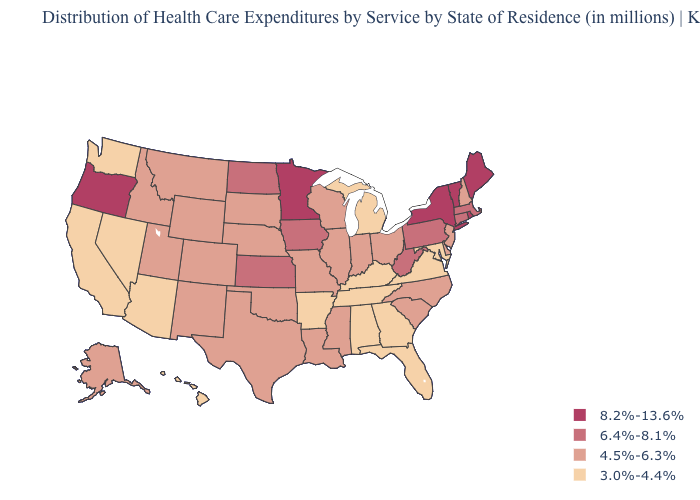Which states have the lowest value in the USA?
Concise answer only. Alabama, Arizona, Arkansas, California, Florida, Georgia, Hawaii, Kentucky, Maryland, Michigan, Nevada, Tennessee, Virginia, Washington. What is the lowest value in states that border Maine?
Short answer required. 4.5%-6.3%. What is the lowest value in the USA?
Keep it brief. 3.0%-4.4%. Which states have the lowest value in the Northeast?
Short answer required. New Hampshire, New Jersey. What is the highest value in states that border Connecticut?
Be succinct. 8.2%-13.6%. What is the lowest value in states that border Iowa?
Answer briefly. 4.5%-6.3%. What is the value of North Carolina?
Be succinct. 4.5%-6.3%. Name the states that have a value in the range 8.2%-13.6%?
Give a very brief answer. Maine, Minnesota, New York, Oregon, Rhode Island, Vermont. Does Utah have a lower value than North Dakota?
Quick response, please. Yes. Does the first symbol in the legend represent the smallest category?
Short answer required. No. Does New Mexico have the lowest value in the West?
Give a very brief answer. No. Does the map have missing data?
Keep it brief. No. Does New Mexico have the same value as Alabama?
Quick response, please. No. What is the lowest value in the South?
Concise answer only. 3.0%-4.4%. Name the states that have a value in the range 4.5%-6.3%?
Quick response, please. Alaska, Colorado, Delaware, Idaho, Illinois, Indiana, Louisiana, Mississippi, Missouri, Montana, Nebraska, New Hampshire, New Jersey, New Mexico, North Carolina, Ohio, Oklahoma, South Carolina, South Dakota, Texas, Utah, Wisconsin, Wyoming. 